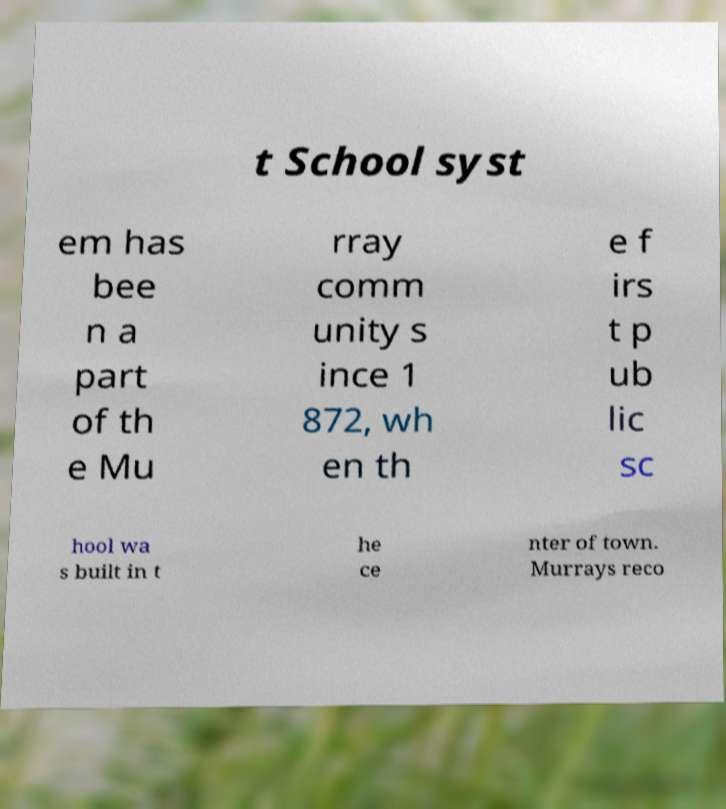Could you assist in decoding the text presented in this image and type it out clearly? t School syst em has bee n a part of th e Mu rray comm unity s ince 1 872, wh en th e f irs t p ub lic sc hool wa s built in t he ce nter of town. Murrays reco 